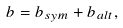<formula> <loc_0><loc_0><loc_500><loc_500>b = b _ { s y m } + b _ { a l t } ,</formula> 